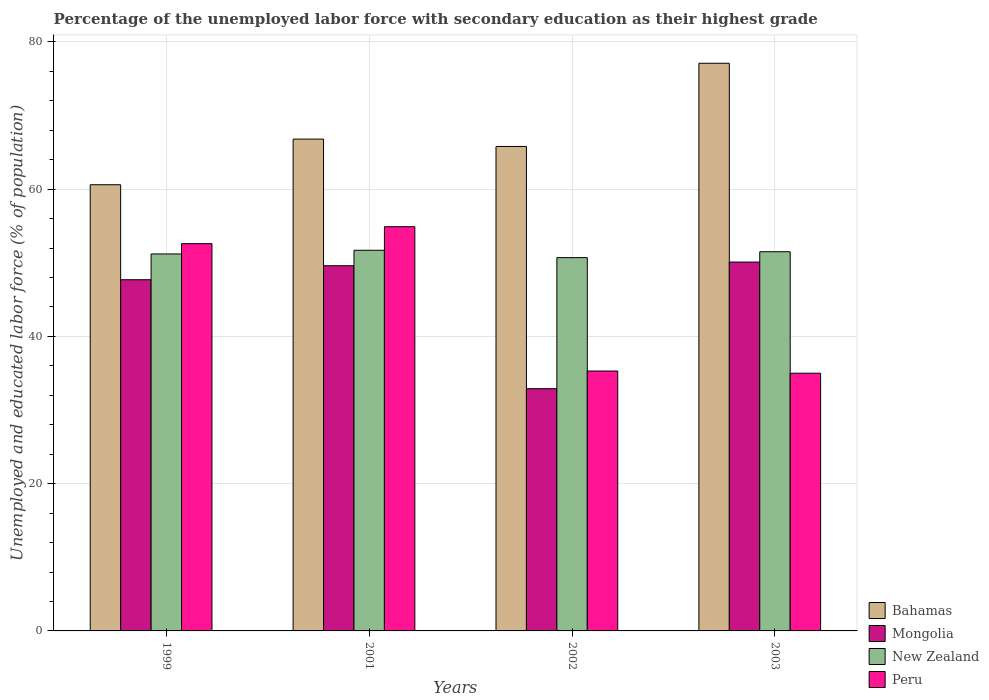How many different coloured bars are there?
Your response must be concise. 4. How many groups of bars are there?
Ensure brevity in your answer.  4. How many bars are there on the 4th tick from the left?
Offer a terse response. 4. In how many cases, is the number of bars for a given year not equal to the number of legend labels?
Give a very brief answer. 0. What is the percentage of the unemployed labor force with secondary education in Peru in 2002?
Make the answer very short. 35.3. Across all years, what is the maximum percentage of the unemployed labor force with secondary education in Bahamas?
Your answer should be compact. 77.1. Across all years, what is the minimum percentage of the unemployed labor force with secondary education in Bahamas?
Keep it short and to the point. 60.6. What is the total percentage of the unemployed labor force with secondary education in Bahamas in the graph?
Give a very brief answer. 270.3. What is the difference between the percentage of the unemployed labor force with secondary education in Bahamas in 1999 and that in 2001?
Ensure brevity in your answer.  -6.2. What is the difference between the percentage of the unemployed labor force with secondary education in Bahamas in 2001 and the percentage of the unemployed labor force with secondary education in Peru in 2002?
Offer a terse response. 31.5. What is the average percentage of the unemployed labor force with secondary education in Bahamas per year?
Offer a terse response. 67.58. In the year 1999, what is the difference between the percentage of the unemployed labor force with secondary education in Bahamas and percentage of the unemployed labor force with secondary education in New Zealand?
Keep it short and to the point. 9.4. What is the ratio of the percentage of the unemployed labor force with secondary education in Peru in 1999 to that in 2003?
Your answer should be very brief. 1.5. Is the percentage of the unemployed labor force with secondary education in Peru in 1999 less than that in 2003?
Offer a terse response. No. Is the difference between the percentage of the unemployed labor force with secondary education in Bahamas in 1999 and 2003 greater than the difference between the percentage of the unemployed labor force with secondary education in New Zealand in 1999 and 2003?
Ensure brevity in your answer.  No. What is the difference between the highest and the second highest percentage of the unemployed labor force with secondary education in Bahamas?
Offer a very short reply. 10.3. In how many years, is the percentage of the unemployed labor force with secondary education in Peru greater than the average percentage of the unemployed labor force with secondary education in Peru taken over all years?
Keep it short and to the point. 2. Is the sum of the percentage of the unemployed labor force with secondary education in New Zealand in 2001 and 2002 greater than the maximum percentage of the unemployed labor force with secondary education in Bahamas across all years?
Provide a short and direct response. Yes. What does the 3rd bar from the left in 2001 represents?
Keep it short and to the point. New Zealand. What does the 4th bar from the right in 2002 represents?
Your response must be concise. Bahamas. Is it the case that in every year, the sum of the percentage of the unemployed labor force with secondary education in Mongolia and percentage of the unemployed labor force with secondary education in Bahamas is greater than the percentage of the unemployed labor force with secondary education in New Zealand?
Provide a succinct answer. Yes. How many bars are there?
Your response must be concise. 16. How many years are there in the graph?
Your answer should be very brief. 4. What is the difference between two consecutive major ticks on the Y-axis?
Ensure brevity in your answer.  20. Are the values on the major ticks of Y-axis written in scientific E-notation?
Your response must be concise. No. Does the graph contain any zero values?
Your answer should be very brief. No. Does the graph contain grids?
Ensure brevity in your answer.  Yes. How are the legend labels stacked?
Keep it short and to the point. Vertical. What is the title of the graph?
Offer a very short reply. Percentage of the unemployed labor force with secondary education as their highest grade. What is the label or title of the X-axis?
Your response must be concise. Years. What is the label or title of the Y-axis?
Ensure brevity in your answer.  Unemployed and educated labor force (% of population). What is the Unemployed and educated labor force (% of population) of Bahamas in 1999?
Your response must be concise. 60.6. What is the Unemployed and educated labor force (% of population) in Mongolia in 1999?
Give a very brief answer. 47.7. What is the Unemployed and educated labor force (% of population) in New Zealand in 1999?
Your answer should be very brief. 51.2. What is the Unemployed and educated labor force (% of population) in Peru in 1999?
Make the answer very short. 52.6. What is the Unemployed and educated labor force (% of population) of Bahamas in 2001?
Your answer should be very brief. 66.8. What is the Unemployed and educated labor force (% of population) of Mongolia in 2001?
Your answer should be compact. 49.6. What is the Unemployed and educated labor force (% of population) in New Zealand in 2001?
Provide a succinct answer. 51.7. What is the Unemployed and educated labor force (% of population) of Peru in 2001?
Provide a short and direct response. 54.9. What is the Unemployed and educated labor force (% of population) in Bahamas in 2002?
Make the answer very short. 65.8. What is the Unemployed and educated labor force (% of population) in Mongolia in 2002?
Make the answer very short. 32.9. What is the Unemployed and educated labor force (% of population) in New Zealand in 2002?
Ensure brevity in your answer.  50.7. What is the Unemployed and educated labor force (% of population) in Peru in 2002?
Your response must be concise. 35.3. What is the Unemployed and educated labor force (% of population) in Bahamas in 2003?
Give a very brief answer. 77.1. What is the Unemployed and educated labor force (% of population) in Mongolia in 2003?
Keep it short and to the point. 50.1. What is the Unemployed and educated labor force (% of population) of New Zealand in 2003?
Your response must be concise. 51.5. What is the Unemployed and educated labor force (% of population) of Peru in 2003?
Your response must be concise. 35. Across all years, what is the maximum Unemployed and educated labor force (% of population) in Bahamas?
Provide a succinct answer. 77.1. Across all years, what is the maximum Unemployed and educated labor force (% of population) of Mongolia?
Make the answer very short. 50.1. Across all years, what is the maximum Unemployed and educated labor force (% of population) of New Zealand?
Offer a very short reply. 51.7. Across all years, what is the maximum Unemployed and educated labor force (% of population) in Peru?
Offer a terse response. 54.9. Across all years, what is the minimum Unemployed and educated labor force (% of population) in Bahamas?
Ensure brevity in your answer.  60.6. Across all years, what is the minimum Unemployed and educated labor force (% of population) of Mongolia?
Your answer should be very brief. 32.9. Across all years, what is the minimum Unemployed and educated labor force (% of population) of New Zealand?
Provide a succinct answer. 50.7. Across all years, what is the minimum Unemployed and educated labor force (% of population) in Peru?
Your answer should be very brief. 35. What is the total Unemployed and educated labor force (% of population) of Bahamas in the graph?
Keep it short and to the point. 270.3. What is the total Unemployed and educated labor force (% of population) of Mongolia in the graph?
Your answer should be compact. 180.3. What is the total Unemployed and educated labor force (% of population) in New Zealand in the graph?
Keep it short and to the point. 205.1. What is the total Unemployed and educated labor force (% of population) in Peru in the graph?
Make the answer very short. 177.8. What is the difference between the Unemployed and educated labor force (% of population) in Bahamas in 1999 and that in 2001?
Give a very brief answer. -6.2. What is the difference between the Unemployed and educated labor force (% of population) in Mongolia in 1999 and that in 2001?
Ensure brevity in your answer.  -1.9. What is the difference between the Unemployed and educated labor force (% of population) in New Zealand in 1999 and that in 2001?
Provide a succinct answer. -0.5. What is the difference between the Unemployed and educated labor force (% of population) of Peru in 1999 and that in 2001?
Offer a terse response. -2.3. What is the difference between the Unemployed and educated labor force (% of population) in Bahamas in 1999 and that in 2002?
Give a very brief answer. -5.2. What is the difference between the Unemployed and educated labor force (% of population) of Bahamas in 1999 and that in 2003?
Provide a succinct answer. -16.5. What is the difference between the Unemployed and educated labor force (% of population) of Mongolia in 1999 and that in 2003?
Offer a very short reply. -2.4. What is the difference between the Unemployed and educated labor force (% of population) of Mongolia in 2001 and that in 2002?
Offer a very short reply. 16.7. What is the difference between the Unemployed and educated labor force (% of population) of New Zealand in 2001 and that in 2002?
Keep it short and to the point. 1. What is the difference between the Unemployed and educated labor force (% of population) of Peru in 2001 and that in 2002?
Offer a very short reply. 19.6. What is the difference between the Unemployed and educated labor force (% of population) of Mongolia in 2001 and that in 2003?
Ensure brevity in your answer.  -0.5. What is the difference between the Unemployed and educated labor force (% of population) in New Zealand in 2001 and that in 2003?
Give a very brief answer. 0.2. What is the difference between the Unemployed and educated labor force (% of population) of Peru in 2001 and that in 2003?
Your answer should be compact. 19.9. What is the difference between the Unemployed and educated labor force (% of population) in Bahamas in 2002 and that in 2003?
Keep it short and to the point. -11.3. What is the difference between the Unemployed and educated labor force (% of population) in Mongolia in 2002 and that in 2003?
Ensure brevity in your answer.  -17.2. What is the difference between the Unemployed and educated labor force (% of population) in Peru in 2002 and that in 2003?
Ensure brevity in your answer.  0.3. What is the difference between the Unemployed and educated labor force (% of population) of Bahamas in 1999 and the Unemployed and educated labor force (% of population) of New Zealand in 2001?
Your response must be concise. 8.9. What is the difference between the Unemployed and educated labor force (% of population) of Bahamas in 1999 and the Unemployed and educated labor force (% of population) of Peru in 2001?
Give a very brief answer. 5.7. What is the difference between the Unemployed and educated labor force (% of population) in Mongolia in 1999 and the Unemployed and educated labor force (% of population) in New Zealand in 2001?
Keep it short and to the point. -4. What is the difference between the Unemployed and educated labor force (% of population) of Mongolia in 1999 and the Unemployed and educated labor force (% of population) of Peru in 2001?
Keep it short and to the point. -7.2. What is the difference between the Unemployed and educated labor force (% of population) of Bahamas in 1999 and the Unemployed and educated labor force (% of population) of Mongolia in 2002?
Ensure brevity in your answer.  27.7. What is the difference between the Unemployed and educated labor force (% of population) of Bahamas in 1999 and the Unemployed and educated labor force (% of population) of New Zealand in 2002?
Your response must be concise. 9.9. What is the difference between the Unemployed and educated labor force (% of population) of Bahamas in 1999 and the Unemployed and educated labor force (% of population) of Peru in 2002?
Your answer should be very brief. 25.3. What is the difference between the Unemployed and educated labor force (% of population) in Bahamas in 1999 and the Unemployed and educated labor force (% of population) in Mongolia in 2003?
Offer a terse response. 10.5. What is the difference between the Unemployed and educated labor force (% of population) of Bahamas in 1999 and the Unemployed and educated labor force (% of population) of New Zealand in 2003?
Offer a terse response. 9.1. What is the difference between the Unemployed and educated labor force (% of population) in Bahamas in 1999 and the Unemployed and educated labor force (% of population) in Peru in 2003?
Your answer should be very brief. 25.6. What is the difference between the Unemployed and educated labor force (% of population) in Mongolia in 1999 and the Unemployed and educated labor force (% of population) in New Zealand in 2003?
Ensure brevity in your answer.  -3.8. What is the difference between the Unemployed and educated labor force (% of population) in New Zealand in 1999 and the Unemployed and educated labor force (% of population) in Peru in 2003?
Ensure brevity in your answer.  16.2. What is the difference between the Unemployed and educated labor force (% of population) of Bahamas in 2001 and the Unemployed and educated labor force (% of population) of Mongolia in 2002?
Your answer should be compact. 33.9. What is the difference between the Unemployed and educated labor force (% of population) in Bahamas in 2001 and the Unemployed and educated labor force (% of population) in Peru in 2002?
Make the answer very short. 31.5. What is the difference between the Unemployed and educated labor force (% of population) of Mongolia in 2001 and the Unemployed and educated labor force (% of population) of New Zealand in 2002?
Make the answer very short. -1.1. What is the difference between the Unemployed and educated labor force (% of population) of Mongolia in 2001 and the Unemployed and educated labor force (% of population) of Peru in 2002?
Your answer should be very brief. 14.3. What is the difference between the Unemployed and educated labor force (% of population) in Bahamas in 2001 and the Unemployed and educated labor force (% of population) in New Zealand in 2003?
Make the answer very short. 15.3. What is the difference between the Unemployed and educated labor force (% of population) of Bahamas in 2001 and the Unemployed and educated labor force (% of population) of Peru in 2003?
Offer a terse response. 31.8. What is the difference between the Unemployed and educated labor force (% of population) in Bahamas in 2002 and the Unemployed and educated labor force (% of population) in Mongolia in 2003?
Give a very brief answer. 15.7. What is the difference between the Unemployed and educated labor force (% of population) in Bahamas in 2002 and the Unemployed and educated labor force (% of population) in Peru in 2003?
Make the answer very short. 30.8. What is the difference between the Unemployed and educated labor force (% of population) of Mongolia in 2002 and the Unemployed and educated labor force (% of population) of New Zealand in 2003?
Ensure brevity in your answer.  -18.6. What is the average Unemployed and educated labor force (% of population) in Bahamas per year?
Offer a terse response. 67.58. What is the average Unemployed and educated labor force (% of population) of Mongolia per year?
Provide a succinct answer. 45.08. What is the average Unemployed and educated labor force (% of population) of New Zealand per year?
Keep it short and to the point. 51.27. What is the average Unemployed and educated labor force (% of population) of Peru per year?
Give a very brief answer. 44.45. In the year 1999, what is the difference between the Unemployed and educated labor force (% of population) in Bahamas and Unemployed and educated labor force (% of population) in Peru?
Give a very brief answer. 8. In the year 1999, what is the difference between the Unemployed and educated labor force (% of population) in Mongolia and Unemployed and educated labor force (% of population) in New Zealand?
Provide a short and direct response. -3.5. In the year 1999, what is the difference between the Unemployed and educated labor force (% of population) in New Zealand and Unemployed and educated labor force (% of population) in Peru?
Provide a succinct answer. -1.4. In the year 2001, what is the difference between the Unemployed and educated labor force (% of population) of Bahamas and Unemployed and educated labor force (% of population) of Mongolia?
Your answer should be very brief. 17.2. In the year 2001, what is the difference between the Unemployed and educated labor force (% of population) in Mongolia and Unemployed and educated labor force (% of population) in New Zealand?
Offer a terse response. -2.1. In the year 2001, what is the difference between the Unemployed and educated labor force (% of population) in Mongolia and Unemployed and educated labor force (% of population) in Peru?
Your response must be concise. -5.3. In the year 2001, what is the difference between the Unemployed and educated labor force (% of population) of New Zealand and Unemployed and educated labor force (% of population) of Peru?
Give a very brief answer. -3.2. In the year 2002, what is the difference between the Unemployed and educated labor force (% of population) in Bahamas and Unemployed and educated labor force (% of population) in Mongolia?
Offer a very short reply. 32.9. In the year 2002, what is the difference between the Unemployed and educated labor force (% of population) of Bahamas and Unemployed and educated labor force (% of population) of New Zealand?
Your answer should be compact. 15.1. In the year 2002, what is the difference between the Unemployed and educated labor force (% of population) in Bahamas and Unemployed and educated labor force (% of population) in Peru?
Your response must be concise. 30.5. In the year 2002, what is the difference between the Unemployed and educated labor force (% of population) in Mongolia and Unemployed and educated labor force (% of population) in New Zealand?
Provide a succinct answer. -17.8. In the year 2002, what is the difference between the Unemployed and educated labor force (% of population) of New Zealand and Unemployed and educated labor force (% of population) of Peru?
Provide a succinct answer. 15.4. In the year 2003, what is the difference between the Unemployed and educated labor force (% of population) of Bahamas and Unemployed and educated labor force (% of population) of New Zealand?
Offer a terse response. 25.6. In the year 2003, what is the difference between the Unemployed and educated labor force (% of population) of Bahamas and Unemployed and educated labor force (% of population) of Peru?
Offer a terse response. 42.1. In the year 2003, what is the difference between the Unemployed and educated labor force (% of population) of Mongolia and Unemployed and educated labor force (% of population) of New Zealand?
Your answer should be very brief. -1.4. In the year 2003, what is the difference between the Unemployed and educated labor force (% of population) of Mongolia and Unemployed and educated labor force (% of population) of Peru?
Keep it short and to the point. 15.1. What is the ratio of the Unemployed and educated labor force (% of population) of Bahamas in 1999 to that in 2001?
Provide a short and direct response. 0.91. What is the ratio of the Unemployed and educated labor force (% of population) of Mongolia in 1999 to that in 2001?
Your response must be concise. 0.96. What is the ratio of the Unemployed and educated labor force (% of population) of New Zealand in 1999 to that in 2001?
Provide a short and direct response. 0.99. What is the ratio of the Unemployed and educated labor force (% of population) of Peru in 1999 to that in 2001?
Provide a short and direct response. 0.96. What is the ratio of the Unemployed and educated labor force (% of population) in Bahamas in 1999 to that in 2002?
Provide a short and direct response. 0.92. What is the ratio of the Unemployed and educated labor force (% of population) in Mongolia in 1999 to that in 2002?
Make the answer very short. 1.45. What is the ratio of the Unemployed and educated labor force (% of population) of New Zealand in 1999 to that in 2002?
Give a very brief answer. 1.01. What is the ratio of the Unemployed and educated labor force (% of population) in Peru in 1999 to that in 2002?
Provide a short and direct response. 1.49. What is the ratio of the Unemployed and educated labor force (% of population) of Bahamas in 1999 to that in 2003?
Your answer should be very brief. 0.79. What is the ratio of the Unemployed and educated labor force (% of population) of Mongolia in 1999 to that in 2003?
Keep it short and to the point. 0.95. What is the ratio of the Unemployed and educated labor force (% of population) of Peru in 1999 to that in 2003?
Provide a short and direct response. 1.5. What is the ratio of the Unemployed and educated labor force (% of population) in Bahamas in 2001 to that in 2002?
Your response must be concise. 1.02. What is the ratio of the Unemployed and educated labor force (% of population) of Mongolia in 2001 to that in 2002?
Provide a succinct answer. 1.51. What is the ratio of the Unemployed and educated labor force (% of population) in New Zealand in 2001 to that in 2002?
Your response must be concise. 1.02. What is the ratio of the Unemployed and educated labor force (% of population) of Peru in 2001 to that in 2002?
Offer a terse response. 1.56. What is the ratio of the Unemployed and educated labor force (% of population) of Bahamas in 2001 to that in 2003?
Your answer should be compact. 0.87. What is the ratio of the Unemployed and educated labor force (% of population) of Peru in 2001 to that in 2003?
Provide a short and direct response. 1.57. What is the ratio of the Unemployed and educated labor force (% of population) in Bahamas in 2002 to that in 2003?
Offer a very short reply. 0.85. What is the ratio of the Unemployed and educated labor force (% of population) in Mongolia in 2002 to that in 2003?
Offer a very short reply. 0.66. What is the ratio of the Unemployed and educated labor force (% of population) of New Zealand in 2002 to that in 2003?
Your answer should be compact. 0.98. What is the ratio of the Unemployed and educated labor force (% of population) in Peru in 2002 to that in 2003?
Make the answer very short. 1.01. What is the difference between the highest and the second highest Unemployed and educated labor force (% of population) in Bahamas?
Provide a succinct answer. 10.3. What is the difference between the highest and the second highest Unemployed and educated labor force (% of population) of Mongolia?
Your answer should be very brief. 0.5. What is the difference between the highest and the lowest Unemployed and educated labor force (% of population) in Bahamas?
Keep it short and to the point. 16.5. What is the difference between the highest and the lowest Unemployed and educated labor force (% of population) of Peru?
Your answer should be compact. 19.9. 